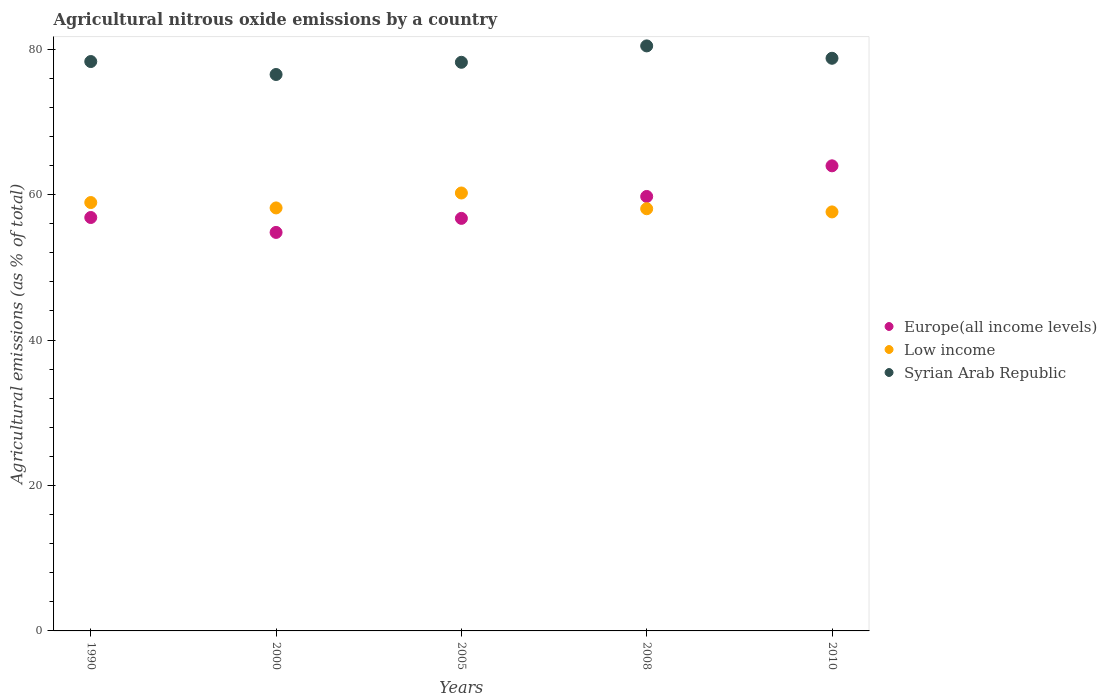What is the amount of agricultural nitrous oxide emitted in Europe(all income levels) in 2000?
Your answer should be very brief. 54.8. Across all years, what is the maximum amount of agricultural nitrous oxide emitted in Europe(all income levels)?
Your answer should be compact. 63.96. Across all years, what is the minimum amount of agricultural nitrous oxide emitted in Syrian Arab Republic?
Give a very brief answer. 76.52. What is the total amount of agricultural nitrous oxide emitted in Syrian Arab Republic in the graph?
Make the answer very short. 392.23. What is the difference between the amount of agricultural nitrous oxide emitted in Syrian Arab Republic in 2008 and that in 2010?
Give a very brief answer. 1.7. What is the difference between the amount of agricultural nitrous oxide emitted in Low income in 2008 and the amount of agricultural nitrous oxide emitted in Europe(all income levels) in 2010?
Keep it short and to the point. -5.9. What is the average amount of agricultural nitrous oxide emitted in Syrian Arab Republic per year?
Ensure brevity in your answer.  78.45. In the year 2008, what is the difference between the amount of agricultural nitrous oxide emitted in Europe(all income levels) and amount of agricultural nitrous oxide emitted in Low income?
Ensure brevity in your answer.  1.69. What is the ratio of the amount of agricultural nitrous oxide emitted in Europe(all income levels) in 1990 to that in 2010?
Your response must be concise. 0.89. What is the difference between the highest and the second highest amount of agricultural nitrous oxide emitted in Europe(all income levels)?
Ensure brevity in your answer.  4.21. What is the difference between the highest and the lowest amount of agricultural nitrous oxide emitted in Europe(all income levels)?
Your response must be concise. 9.16. In how many years, is the amount of agricultural nitrous oxide emitted in Low income greater than the average amount of agricultural nitrous oxide emitted in Low income taken over all years?
Your answer should be very brief. 2. Is the sum of the amount of agricultural nitrous oxide emitted in Syrian Arab Republic in 2008 and 2010 greater than the maximum amount of agricultural nitrous oxide emitted in Europe(all income levels) across all years?
Give a very brief answer. Yes. Is it the case that in every year, the sum of the amount of agricultural nitrous oxide emitted in Syrian Arab Republic and amount of agricultural nitrous oxide emitted in Europe(all income levels)  is greater than the amount of agricultural nitrous oxide emitted in Low income?
Give a very brief answer. Yes. Does the amount of agricultural nitrous oxide emitted in Low income monotonically increase over the years?
Keep it short and to the point. No. How many years are there in the graph?
Give a very brief answer. 5. What is the difference between two consecutive major ticks on the Y-axis?
Provide a succinct answer. 20. Does the graph contain any zero values?
Offer a terse response. No. Does the graph contain grids?
Offer a very short reply. No. Where does the legend appear in the graph?
Your answer should be very brief. Center right. What is the title of the graph?
Provide a short and direct response. Agricultural nitrous oxide emissions by a country. What is the label or title of the X-axis?
Your answer should be compact. Years. What is the label or title of the Y-axis?
Keep it short and to the point. Agricultural emissions (as % of total). What is the Agricultural emissions (as % of total) in Europe(all income levels) in 1990?
Provide a succinct answer. 56.85. What is the Agricultural emissions (as % of total) in Low income in 1990?
Make the answer very short. 58.91. What is the Agricultural emissions (as % of total) of Syrian Arab Republic in 1990?
Your answer should be compact. 78.3. What is the Agricultural emissions (as % of total) of Europe(all income levels) in 2000?
Provide a short and direct response. 54.8. What is the Agricultural emissions (as % of total) in Low income in 2000?
Provide a short and direct response. 58.17. What is the Agricultural emissions (as % of total) in Syrian Arab Republic in 2000?
Your answer should be compact. 76.52. What is the Agricultural emissions (as % of total) in Europe(all income levels) in 2005?
Keep it short and to the point. 56.74. What is the Agricultural emissions (as % of total) of Low income in 2005?
Offer a very short reply. 60.22. What is the Agricultural emissions (as % of total) of Syrian Arab Republic in 2005?
Your answer should be very brief. 78.2. What is the Agricultural emissions (as % of total) in Europe(all income levels) in 2008?
Your response must be concise. 59.75. What is the Agricultural emissions (as % of total) of Low income in 2008?
Make the answer very short. 58.06. What is the Agricultural emissions (as % of total) of Syrian Arab Republic in 2008?
Keep it short and to the point. 80.45. What is the Agricultural emissions (as % of total) of Europe(all income levels) in 2010?
Provide a short and direct response. 63.96. What is the Agricultural emissions (as % of total) in Low income in 2010?
Offer a terse response. 57.62. What is the Agricultural emissions (as % of total) in Syrian Arab Republic in 2010?
Provide a succinct answer. 78.75. Across all years, what is the maximum Agricultural emissions (as % of total) of Europe(all income levels)?
Your response must be concise. 63.96. Across all years, what is the maximum Agricultural emissions (as % of total) in Low income?
Ensure brevity in your answer.  60.22. Across all years, what is the maximum Agricultural emissions (as % of total) of Syrian Arab Republic?
Your answer should be compact. 80.45. Across all years, what is the minimum Agricultural emissions (as % of total) of Europe(all income levels)?
Provide a succinct answer. 54.8. Across all years, what is the minimum Agricultural emissions (as % of total) in Low income?
Provide a succinct answer. 57.62. Across all years, what is the minimum Agricultural emissions (as % of total) of Syrian Arab Republic?
Your answer should be very brief. 76.52. What is the total Agricultural emissions (as % of total) of Europe(all income levels) in the graph?
Your answer should be very brief. 292.1. What is the total Agricultural emissions (as % of total) in Low income in the graph?
Make the answer very short. 292.99. What is the total Agricultural emissions (as % of total) in Syrian Arab Republic in the graph?
Make the answer very short. 392.23. What is the difference between the Agricultural emissions (as % of total) in Europe(all income levels) in 1990 and that in 2000?
Offer a terse response. 2.05. What is the difference between the Agricultural emissions (as % of total) in Low income in 1990 and that in 2000?
Offer a very short reply. 0.74. What is the difference between the Agricultural emissions (as % of total) in Syrian Arab Republic in 1990 and that in 2000?
Your answer should be compact. 1.78. What is the difference between the Agricultural emissions (as % of total) of Europe(all income levels) in 1990 and that in 2005?
Your answer should be very brief. 0.12. What is the difference between the Agricultural emissions (as % of total) in Low income in 1990 and that in 2005?
Your answer should be compact. -1.31. What is the difference between the Agricultural emissions (as % of total) of Syrian Arab Republic in 1990 and that in 2005?
Offer a terse response. 0.1. What is the difference between the Agricultural emissions (as % of total) in Europe(all income levels) in 1990 and that in 2008?
Provide a short and direct response. -2.89. What is the difference between the Agricultural emissions (as % of total) of Low income in 1990 and that in 2008?
Ensure brevity in your answer.  0.85. What is the difference between the Agricultural emissions (as % of total) of Syrian Arab Republic in 1990 and that in 2008?
Make the answer very short. -2.15. What is the difference between the Agricultural emissions (as % of total) in Europe(all income levels) in 1990 and that in 2010?
Provide a short and direct response. -7.11. What is the difference between the Agricultural emissions (as % of total) in Low income in 1990 and that in 2010?
Give a very brief answer. 1.29. What is the difference between the Agricultural emissions (as % of total) in Syrian Arab Republic in 1990 and that in 2010?
Your answer should be very brief. -0.45. What is the difference between the Agricultural emissions (as % of total) of Europe(all income levels) in 2000 and that in 2005?
Ensure brevity in your answer.  -1.93. What is the difference between the Agricultural emissions (as % of total) of Low income in 2000 and that in 2005?
Make the answer very short. -2.05. What is the difference between the Agricultural emissions (as % of total) in Syrian Arab Republic in 2000 and that in 2005?
Provide a succinct answer. -1.68. What is the difference between the Agricultural emissions (as % of total) of Europe(all income levels) in 2000 and that in 2008?
Make the answer very short. -4.94. What is the difference between the Agricultural emissions (as % of total) of Low income in 2000 and that in 2008?
Offer a terse response. 0.11. What is the difference between the Agricultural emissions (as % of total) in Syrian Arab Republic in 2000 and that in 2008?
Provide a succinct answer. -3.93. What is the difference between the Agricultural emissions (as % of total) of Europe(all income levels) in 2000 and that in 2010?
Your answer should be compact. -9.16. What is the difference between the Agricultural emissions (as % of total) of Low income in 2000 and that in 2010?
Offer a terse response. 0.55. What is the difference between the Agricultural emissions (as % of total) in Syrian Arab Republic in 2000 and that in 2010?
Ensure brevity in your answer.  -2.23. What is the difference between the Agricultural emissions (as % of total) of Europe(all income levels) in 2005 and that in 2008?
Your response must be concise. -3.01. What is the difference between the Agricultural emissions (as % of total) of Low income in 2005 and that in 2008?
Offer a very short reply. 2.16. What is the difference between the Agricultural emissions (as % of total) of Syrian Arab Republic in 2005 and that in 2008?
Provide a short and direct response. -2.25. What is the difference between the Agricultural emissions (as % of total) of Europe(all income levels) in 2005 and that in 2010?
Offer a very short reply. -7.23. What is the difference between the Agricultural emissions (as % of total) in Low income in 2005 and that in 2010?
Make the answer very short. 2.6. What is the difference between the Agricultural emissions (as % of total) of Syrian Arab Republic in 2005 and that in 2010?
Keep it short and to the point. -0.55. What is the difference between the Agricultural emissions (as % of total) in Europe(all income levels) in 2008 and that in 2010?
Give a very brief answer. -4.21. What is the difference between the Agricultural emissions (as % of total) in Low income in 2008 and that in 2010?
Keep it short and to the point. 0.44. What is the difference between the Agricultural emissions (as % of total) in Syrian Arab Republic in 2008 and that in 2010?
Offer a very short reply. 1.7. What is the difference between the Agricultural emissions (as % of total) in Europe(all income levels) in 1990 and the Agricultural emissions (as % of total) in Low income in 2000?
Your answer should be very brief. -1.32. What is the difference between the Agricultural emissions (as % of total) of Europe(all income levels) in 1990 and the Agricultural emissions (as % of total) of Syrian Arab Republic in 2000?
Your answer should be very brief. -19.67. What is the difference between the Agricultural emissions (as % of total) in Low income in 1990 and the Agricultural emissions (as % of total) in Syrian Arab Republic in 2000?
Your answer should be very brief. -17.61. What is the difference between the Agricultural emissions (as % of total) of Europe(all income levels) in 1990 and the Agricultural emissions (as % of total) of Low income in 2005?
Offer a terse response. -3.37. What is the difference between the Agricultural emissions (as % of total) in Europe(all income levels) in 1990 and the Agricultural emissions (as % of total) in Syrian Arab Republic in 2005?
Make the answer very short. -21.35. What is the difference between the Agricultural emissions (as % of total) of Low income in 1990 and the Agricultural emissions (as % of total) of Syrian Arab Republic in 2005?
Provide a short and direct response. -19.29. What is the difference between the Agricultural emissions (as % of total) in Europe(all income levels) in 1990 and the Agricultural emissions (as % of total) in Low income in 2008?
Offer a terse response. -1.21. What is the difference between the Agricultural emissions (as % of total) of Europe(all income levels) in 1990 and the Agricultural emissions (as % of total) of Syrian Arab Republic in 2008?
Give a very brief answer. -23.6. What is the difference between the Agricultural emissions (as % of total) in Low income in 1990 and the Agricultural emissions (as % of total) in Syrian Arab Republic in 2008?
Keep it short and to the point. -21.54. What is the difference between the Agricultural emissions (as % of total) in Europe(all income levels) in 1990 and the Agricultural emissions (as % of total) in Low income in 2010?
Keep it short and to the point. -0.77. What is the difference between the Agricultural emissions (as % of total) in Europe(all income levels) in 1990 and the Agricultural emissions (as % of total) in Syrian Arab Republic in 2010?
Keep it short and to the point. -21.9. What is the difference between the Agricultural emissions (as % of total) in Low income in 1990 and the Agricultural emissions (as % of total) in Syrian Arab Republic in 2010?
Your answer should be very brief. -19.84. What is the difference between the Agricultural emissions (as % of total) of Europe(all income levels) in 2000 and the Agricultural emissions (as % of total) of Low income in 2005?
Provide a succinct answer. -5.42. What is the difference between the Agricultural emissions (as % of total) of Europe(all income levels) in 2000 and the Agricultural emissions (as % of total) of Syrian Arab Republic in 2005?
Provide a short and direct response. -23.4. What is the difference between the Agricultural emissions (as % of total) of Low income in 2000 and the Agricultural emissions (as % of total) of Syrian Arab Republic in 2005?
Your response must be concise. -20.03. What is the difference between the Agricultural emissions (as % of total) in Europe(all income levels) in 2000 and the Agricultural emissions (as % of total) in Low income in 2008?
Your response must be concise. -3.26. What is the difference between the Agricultural emissions (as % of total) of Europe(all income levels) in 2000 and the Agricultural emissions (as % of total) of Syrian Arab Republic in 2008?
Your answer should be very brief. -25.65. What is the difference between the Agricultural emissions (as % of total) of Low income in 2000 and the Agricultural emissions (as % of total) of Syrian Arab Republic in 2008?
Your answer should be compact. -22.28. What is the difference between the Agricultural emissions (as % of total) in Europe(all income levels) in 2000 and the Agricultural emissions (as % of total) in Low income in 2010?
Your response must be concise. -2.82. What is the difference between the Agricultural emissions (as % of total) of Europe(all income levels) in 2000 and the Agricultural emissions (as % of total) of Syrian Arab Republic in 2010?
Make the answer very short. -23.95. What is the difference between the Agricultural emissions (as % of total) in Low income in 2000 and the Agricultural emissions (as % of total) in Syrian Arab Republic in 2010?
Your answer should be very brief. -20.58. What is the difference between the Agricultural emissions (as % of total) in Europe(all income levels) in 2005 and the Agricultural emissions (as % of total) in Low income in 2008?
Your answer should be very brief. -1.32. What is the difference between the Agricultural emissions (as % of total) in Europe(all income levels) in 2005 and the Agricultural emissions (as % of total) in Syrian Arab Republic in 2008?
Make the answer very short. -23.72. What is the difference between the Agricultural emissions (as % of total) of Low income in 2005 and the Agricultural emissions (as % of total) of Syrian Arab Republic in 2008?
Provide a short and direct response. -20.23. What is the difference between the Agricultural emissions (as % of total) of Europe(all income levels) in 2005 and the Agricultural emissions (as % of total) of Low income in 2010?
Your answer should be very brief. -0.89. What is the difference between the Agricultural emissions (as % of total) in Europe(all income levels) in 2005 and the Agricultural emissions (as % of total) in Syrian Arab Republic in 2010?
Give a very brief answer. -22.02. What is the difference between the Agricultural emissions (as % of total) in Low income in 2005 and the Agricultural emissions (as % of total) in Syrian Arab Republic in 2010?
Offer a terse response. -18.53. What is the difference between the Agricultural emissions (as % of total) in Europe(all income levels) in 2008 and the Agricultural emissions (as % of total) in Low income in 2010?
Ensure brevity in your answer.  2.13. What is the difference between the Agricultural emissions (as % of total) in Europe(all income levels) in 2008 and the Agricultural emissions (as % of total) in Syrian Arab Republic in 2010?
Give a very brief answer. -19.01. What is the difference between the Agricultural emissions (as % of total) of Low income in 2008 and the Agricultural emissions (as % of total) of Syrian Arab Republic in 2010?
Offer a terse response. -20.69. What is the average Agricultural emissions (as % of total) in Europe(all income levels) per year?
Make the answer very short. 58.42. What is the average Agricultural emissions (as % of total) in Low income per year?
Provide a short and direct response. 58.6. What is the average Agricultural emissions (as % of total) of Syrian Arab Republic per year?
Keep it short and to the point. 78.45. In the year 1990, what is the difference between the Agricultural emissions (as % of total) in Europe(all income levels) and Agricultural emissions (as % of total) in Low income?
Make the answer very short. -2.06. In the year 1990, what is the difference between the Agricultural emissions (as % of total) in Europe(all income levels) and Agricultural emissions (as % of total) in Syrian Arab Republic?
Ensure brevity in your answer.  -21.45. In the year 1990, what is the difference between the Agricultural emissions (as % of total) of Low income and Agricultural emissions (as % of total) of Syrian Arab Republic?
Keep it short and to the point. -19.39. In the year 2000, what is the difference between the Agricultural emissions (as % of total) in Europe(all income levels) and Agricultural emissions (as % of total) in Low income?
Your answer should be very brief. -3.37. In the year 2000, what is the difference between the Agricultural emissions (as % of total) of Europe(all income levels) and Agricultural emissions (as % of total) of Syrian Arab Republic?
Ensure brevity in your answer.  -21.72. In the year 2000, what is the difference between the Agricultural emissions (as % of total) in Low income and Agricultural emissions (as % of total) in Syrian Arab Republic?
Provide a succinct answer. -18.35. In the year 2005, what is the difference between the Agricultural emissions (as % of total) in Europe(all income levels) and Agricultural emissions (as % of total) in Low income?
Provide a short and direct response. -3.49. In the year 2005, what is the difference between the Agricultural emissions (as % of total) of Europe(all income levels) and Agricultural emissions (as % of total) of Syrian Arab Republic?
Provide a short and direct response. -21.46. In the year 2005, what is the difference between the Agricultural emissions (as % of total) in Low income and Agricultural emissions (as % of total) in Syrian Arab Republic?
Make the answer very short. -17.98. In the year 2008, what is the difference between the Agricultural emissions (as % of total) of Europe(all income levels) and Agricultural emissions (as % of total) of Low income?
Make the answer very short. 1.69. In the year 2008, what is the difference between the Agricultural emissions (as % of total) of Europe(all income levels) and Agricultural emissions (as % of total) of Syrian Arab Republic?
Your response must be concise. -20.71. In the year 2008, what is the difference between the Agricultural emissions (as % of total) in Low income and Agricultural emissions (as % of total) in Syrian Arab Republic?
Give a very brief answer. -22.39. In the year 2010, what is the difference between the Agricultural emissions (as % of total) in Europe(all income levels) and Agricultural emissions (as % of total) in Low income?
Give a very brief answer. 6.34. In the year 2010, what is the difference between the Agricultural emissions (as % of total) of Europe(all income levels) and Agricultural emissions (as % of total) of Syrian Arab Republic?
Offer a very short reply. -14.79. In the year 2010, what is the difference between the Agricultural emissions (as % of total) in Low income and Agricultural emissions (as % of total) in Syrian Arab Republic?
Offer a terse response. -21.13. What is the ratio of the Agricultural emissions (as % of total) in Europe(all income levels) in 1990 to that in 2000?
Your answer should be very brief. 1.04. What is the ratio of the Agricultural emissions (as % of total) of Low income in 1990 to that in 2000?
Give a very brief answer. 1.01. What is the ratio of the Agricultural emissions (as % of total) in Syrian Arab Republic in 1990 to that in 2000?
Offer a very short reply. 1.02. What is the ratio of the Agricultural emissions (as % of total) in Low income in 1990 to that in 2005?
Your answer should be very brief. 0.98. What is the ratio of the Agricultural emissions (as % of total) of Europe(all income levels) in 1990 to that in 2008?
Your answer should be compact. 0.95. What is the ratio of the Agricultural emissions (as % of total) in Low income in 1990 to that in 2008?
Provide a short and direct response. 1.01. What is the ratio of the Agricultural emissions (as % of total) of Syrian Arab Republic in 1990 to that in 2008?
Make the answer very short. 0.97. What is the ratio of the Agricultural emissions (as % of total) of Low income in 1990 to that in 2010?
Ensure brevity in your answer.  1.02. What is the ratio of the Agricultural emissions (as % of total) of Syrian Arab Republic in 1990 to that in 2010?
Offer a very short reply. 0.99. What is the ratio of the Agricultural emissions (as % of total) in Europe(all income levels) in 2000 to that in 2005?
Make the answer very short. 0.97. What is the ratio of the Agricultural emissions (as % of total) in Low income in 2000 to that in 2005?
Provide a short and direct response. 0.97. What is the ratio of the Agricultural emissions (as % of total) in Syrian Arab Republic in 2000 to that in 2005?
Keep it short and to the point. 0.98. What is the ratio of the Agricultural emissions (as % of total) in Europe(all income levels) in 2000 to that in 2008?
Your answer should be very brief. 0.92. What is the ratio of the Agricultural emissions (as % of total) of Low income in 2000 to that in 2008?
Your response must be concise. 1. What is the ratio of the Agricultural emissions (as % of total) in Syrian Arab Republic in 2000 to that in 2008?
Make the answer very short. 0.95. What is the ratio of the Agricultural emissions (as % of total) of Europe(all income levels) in 2000 to that in 2010?
Your response must be concise. 0.86. What is the ratio of the Agricultural emissions (as % of total) of Low income in 2000 to that in 2010?
Provide a succinct answer. 1.01. What is the ratio of the Agricultural emissions (as % of total) of Syrian Arab Republic in 2000 to that in 2010?
Provide a short and direct response. 0.97. What is the ratio of the Agricultural emissions (as % of total) of Europe(all income levels) in 2005 to that in 2008?
Offer a very short reply. 0.95. What is the ratio of the Agricultural emissions (as % of total) of Low income in 2005 to that in 2008?
Offer a very short reply. 1.04. What is the ratio of the Agricultural emissions (as % of total) of Europe(all income levels) in 2005 to that in 2010?
Provide a short and direct response. 0.89. What is the ratio of the Agricultural emissions (as % of total) of Low income in 2005 to that in 2010?
Ensure brevity in your answer.  1.05. What is the ratio of the Agricultural emissions (as % of total) in Syrian Arab Republic in 2005 to that in 2010?
Make the answer very short. 0.99. What is the ratio of the Agricultural emissions (as % of total) in Europe(all income levels) in 2008 to that in 2010?
Your answer should be very brief. 0.93. What is the ratio of the Agricultural emissions (as % of total) of Low income in 2008 to that in 2010?
Provide a short and direct response. 1.01. What is the ratio of the Agricultural emissions (as % of total) in Syrian Arab Republic in 2008 to that in 2010?
Provide a short and direct response. 1.02. What is the difference between the highest and the second highest Agricultural emissions (as % of total) of Europe(all income levels)?
Your answer should be very brief. 4.21. What is the difference between the highest and the second highest Agricultural emissions (as % of total) in Low income?
Your answer should be very brief. 1.31. What is the difference between the highest and the second highest Agricultural emissions (as % of total) of Syrian Arab Republic?
Keep it short and to the point. 1.7. What is the difference between the highest and the lowest Agricultural emissions (as % of total) of Europe(all income levels)?
Keep it short and to the point. 9.16. What is the difference between the highest and the lowest Agricultural emissions (as % of total) of Low income?
Offer a terse response. 2.6. What is the difference between the highest and the lowest Agricultural emissions (as % of total) of Syrian Arab Republic?
Offer a terse response. 3.93. 